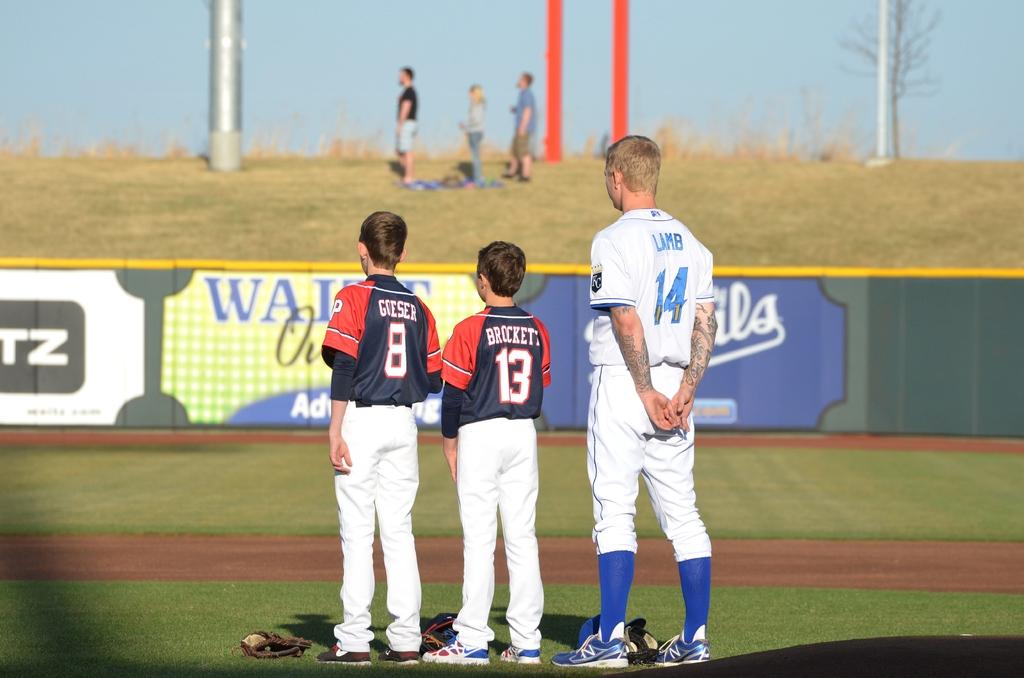What's the name of the player in the middle?
Provide a short and direct response. Brockett. What's the name of the player on the left?
Your answer should be very brief. Goeser. 